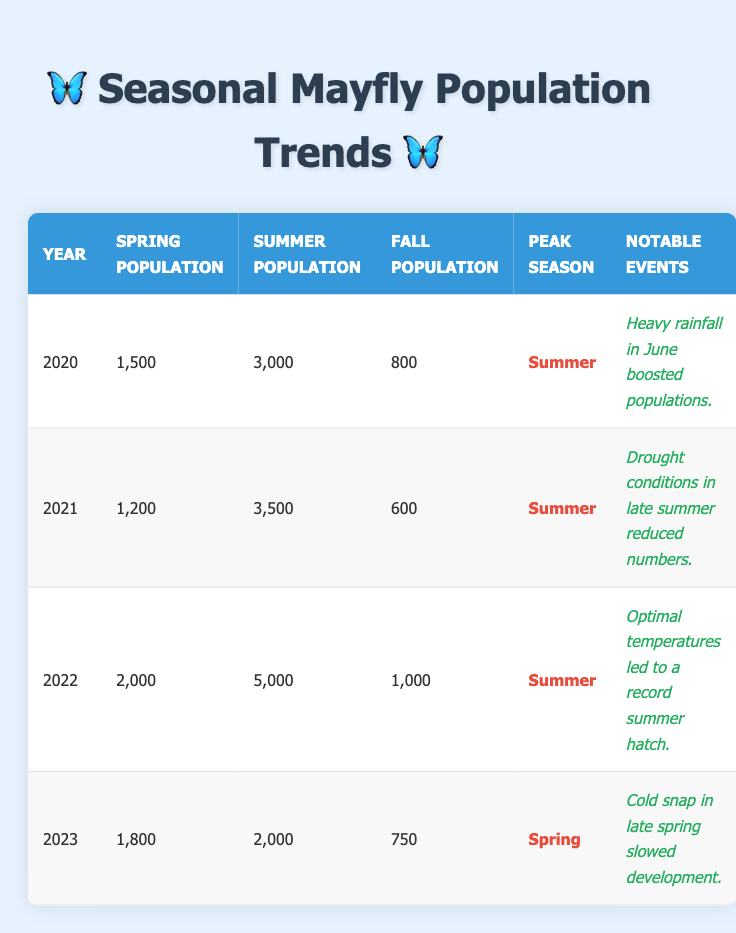What was the peak mayfly population season in 2022? According to the table, the peak season in 2022 is listed in the "Peak Season" column as "Summer."
Answer: Summer How many mayflies were recorded in the summer of 2021? The "Summer Population" for the year 2021 is recorded as 3,500 in the table.
Answer: 3,500 What was the total summer population from 2020 to 2023? To find the total summer population, we sum the summer populations over the four years: 3,000 (2020) + 3,500 (2021) + 5,000 (2022) + 2,000 (2023) = 13,500.
Answer: 13,500 In which year did the spring population see the highest number? By examining the "Spring Population" column, we find that 2022 has the highest spring population at 2,000, compared to the other years.
Answer: 2022 Was the notable event in 2023 beneficial for the mayfly population? The notable event listed for 2023 was a "Cold snap in late spring," which is generally detrimental to development, indicating it likely did not benefit the population.
Answer: No What was the difference in summer populations between 2021 and 2023? The summer population in 2021 was 3,500, and in 2023 it was 2,000. Therefore, the difference is 3,500 - 2,000 = 1,500.
Answer: 1,500 Did the mayfly population peak in the spring or summer for 2020? The table shows that the peak season for 2020 is "Summer," so it did not peak in spring.
Answer: No, it peaked in summer What was the fall population in 2022 compared to 2023? For 2022, the fall population is 1,000, and for 2023, it is 750. Comparing these, 1,000 > 750, so 2022 had a higher fall population.
Answer: 2022 had a higher fall population What was the average spring population across all four years? To find the average, we calculate: (1,500 + 1,200 + 2,000 + 1,800) / 4 = 1,625.
Answer: 1,625 Was there an increase in the summer population from 2020 to 2022? The summer population increased from 3,000 in 2020 to 5,000 in 2022, which reflects a clear increase.
Answer: Yes 